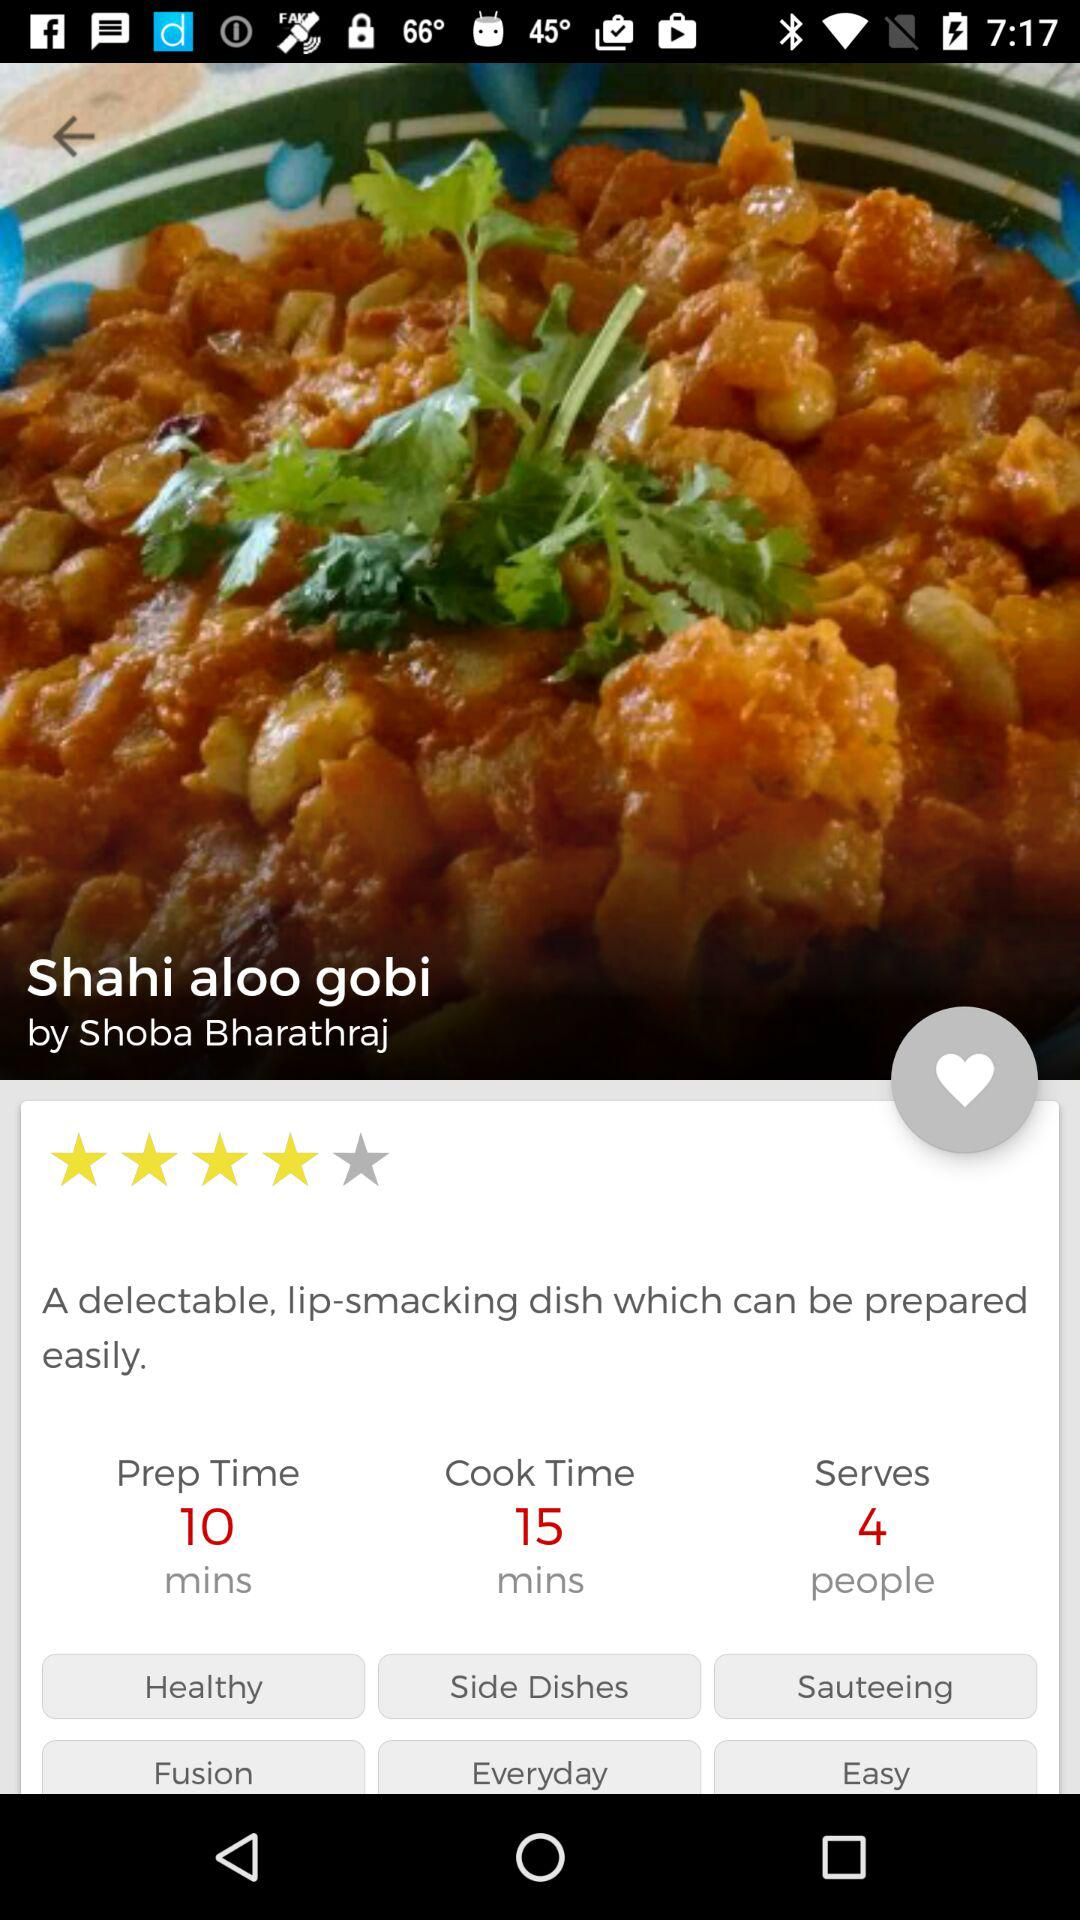What is the chef name? The chef name is Shoba Bharathraj. 